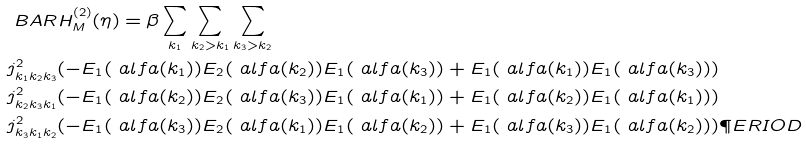<formula> <loc_0><loc_0><loc_500><loc_500>& \ B A R H _ { M } ^ { ( 2 ) } ( \eta ) = \beta \sum _ { k _ { 1 } } \sum _ { k _ { 2 } > k _ { 1 } } \sum _ { k _ { 3 } > k _ { 2 } } \\ & j ^ { 2 } _ { k _ { 1 } k _ { 2 } k _ { 3 } } ( - E _ { 1 } ( \ a l f a ( k _ { 1 } ) ) E _ { 2 } ( \ a l f a ( k _ { 2 } ) ) E _ { 1 } ( \ a l f a ( k _ { 3 } ) ) + E _ { 1 } ( \ a l f a ( k _ { 1 } ) ) E _ { 1 } ( \ a l f a ( k _ { 3 } ) ) ) \\ & j ^ { 2 } _ { k _ { 2 } k _ { 3 } k _ { 1 } } ( - E _ { 1 } ( \ a l f a ( k _ { 2 } ) ) E _ { 2 } ( \ a l f a ( k _ { 3 } ) ) E _ { 1 } ( \ a l f a ( k _ { 1 } ) ) + E _ { 1 } ( \ a l f a ( k _ { 2 } ) ) E _ { 1 } ( \ a l f a ( k _ { 1 } ) ) ) \\ & j ^ { 2 } _ { k _ { 3 } k _ { 1 } k _ { 2 } } ( - E _ { 1 } ( \ a l f a ( k _ { 3 } ) ) E _ { 2 } ( \ a l f a ( k _ { 1 } ) ) E _ { 1 } ( \ a l f a ( k _ { 2 } ) ) + E _ { 1 } ( \ a l f a ( k _ { 3 } ) ) E _ { 1 } ( \ a l f a ( k _ { 2 } ) ) ) \P E R I O D</formula> 